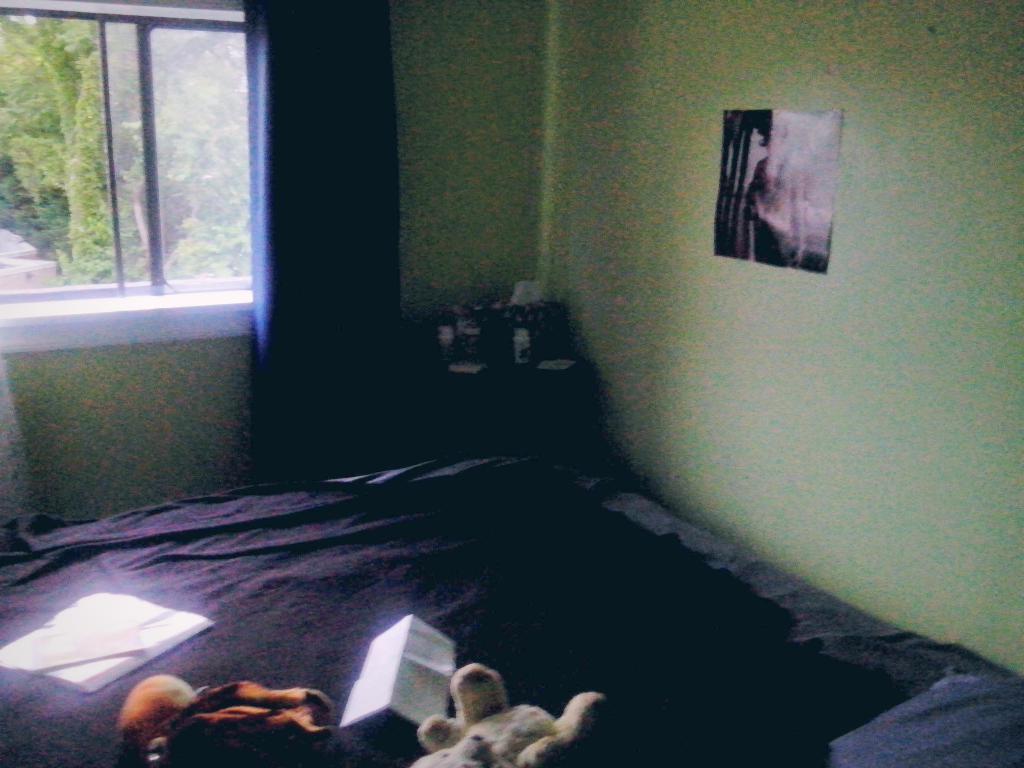Please provide a concise description of this image. We can see dolls,book and papers on bed and we can see poster on a wall,window and curtain,through this window we can see trees. 